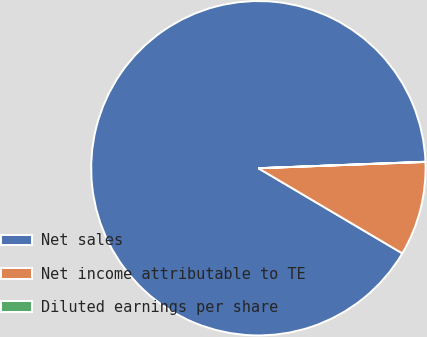Convert chart to OTSL. <chart><loc_0><loc_0><loc_500><loc_500><pie_chart><fcel>Net sales<fcel>Net income attributable to TE<fcel>Diluted earnings per share<nl><fcel>90.88%<fcel>9.1%<fcel>0.02%<nl></chart> 